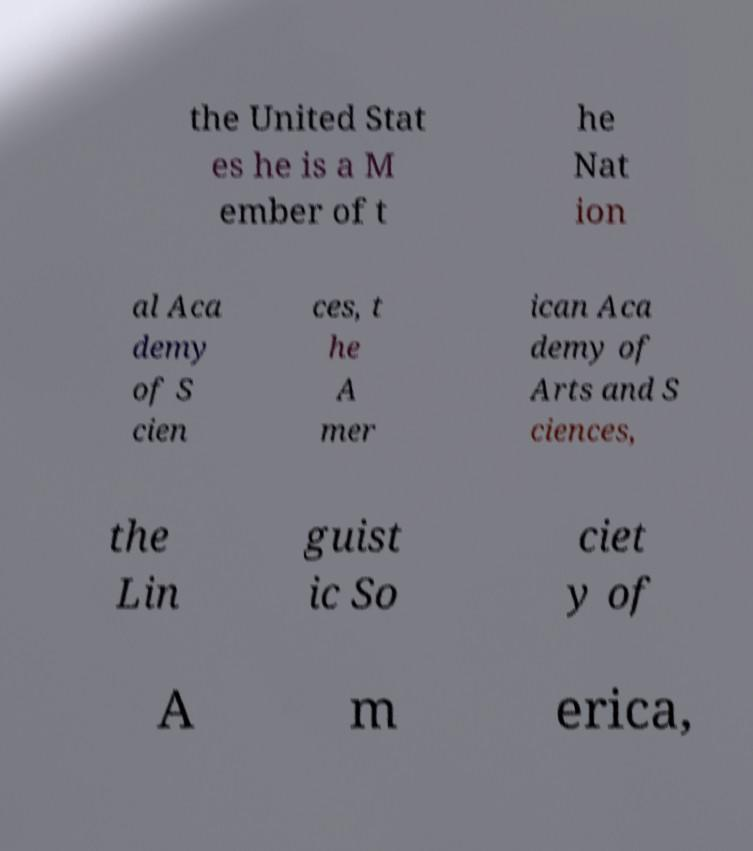There's text embedded in this image that I need extracted. Can you transcribe it verbatim? the United Stat es he is a M ember of t he Nat ion al Aca demy of S cien ces, t he A mer ican Aca demy of Arts and S ciences, the Lin guist ic So ciet y of A m erica, 